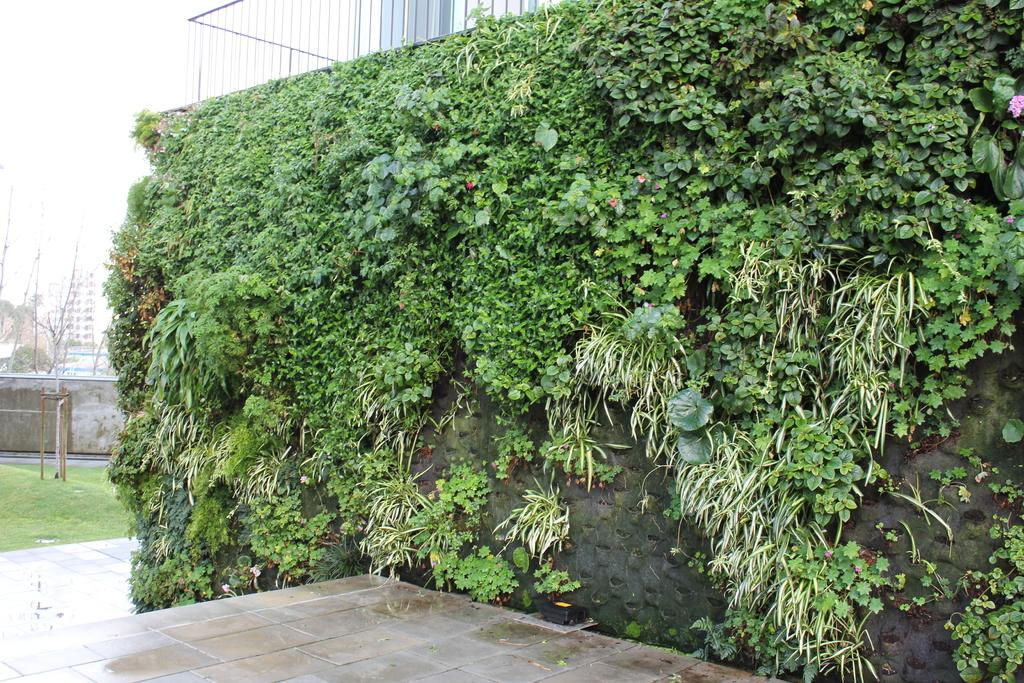What type of decoration is on the wall of the building in the image? There are plants on the wall of the building in the image. What architectural feature can be seen in the image? There are iron grills in the image. What is the main structure in the image? There is a building in the image. What type of vegetation is present in the image? There are trees in the image. What is visible in the background of the image? The sky is visible in the image. What type of thread is being used to create the divisions in the building's system in the image? There is no mention of thread, divisions, or a system in the image; it features plants on a building wall, iron grills, a building, trees, and the sky. 